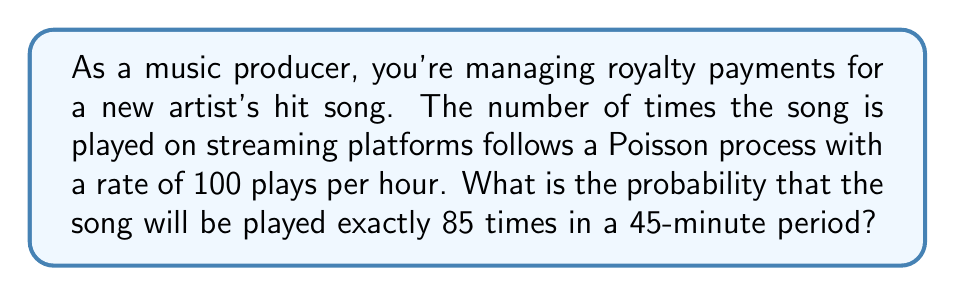Solve this math problem. Let's approach this step-by-step:

1) First, we need to adjust the rate for the given time period. The rate is 100 plays per hour, but we're looking at a 45-minute period.

   45 minutes = 45/60 = 3/4 of an hour

   So, the rate for 45 minutes is: $\lambda = 100 * (3/4) = 75$ plays

2) We're looking for the probability of exactly 85 plays in this period. This follows a Poisson distribution with $\lambda = 75$.

3) The probability mass function for a Poisson distribution is:

   $$ P(X = k) = \frac{e^{-\lambda} \lambda^k}{k!} $$

   Where $k$ is the number of occurrences we're interested in (85 in this case).

4) Plugging in our values:

   $$ P(X = 85) = \frac{e^{-75} 75^{85}}{85!} $$

5) This can be calculated using a calculator or programming language. Using Python:

   ```python
   from math import exp, factorial
   prob = (exp(-75) * 75**85) / factorial(85)
   print(prob)
   ```

6) The result is approximately 0.0308 or 3.08%.
Answer: 0.0308 or 3.08% 